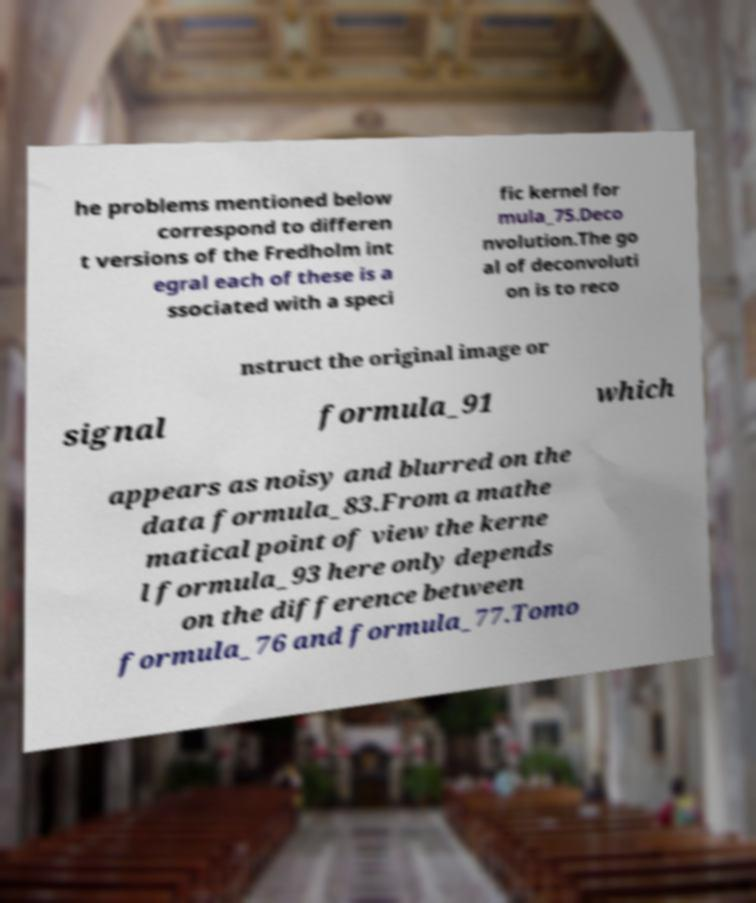Can you accurately transcribe the text from the provided image for me? he problems mentioned below correspond to differen t versions of the Fredholm int egral each of these is a ssociated with a speci fic kernel for mula_75.Deco nvolution.The go al of deconvoluti on is to reco nstruct the original image or signal formula_91 which appears as noisy and blurred on the data formula_83.From a mathe matical point of view the kerne l formula_93 here only depends on the difference between formula_76 and formula_77.Tomo 